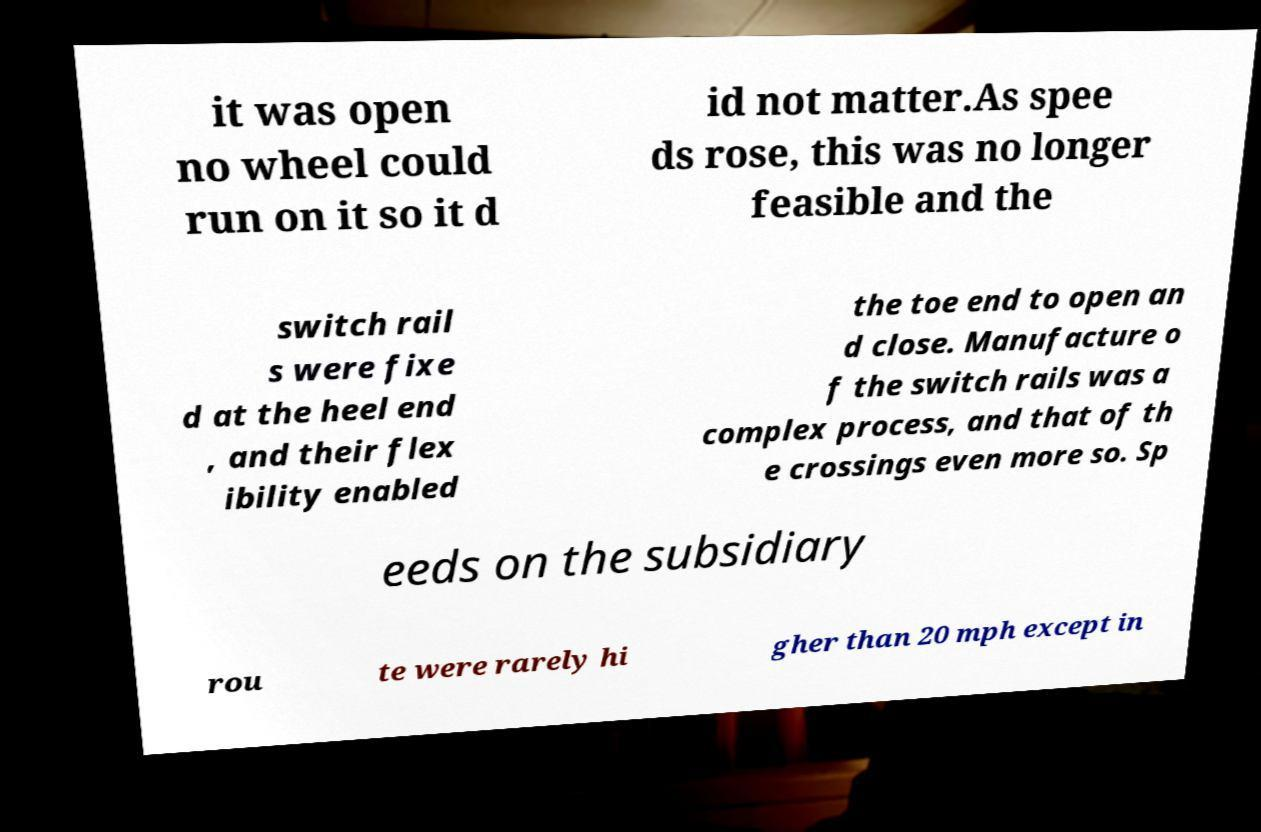I need the written content from this picture converted into text. Can you do that? it was open no wheel could run on it so it d id not matter.As spee ds rose, this was no longer feasible and the switch rail s were fixe d at the heel end , and their flex ibility enabled the toe end to open an d close. Manufacture o f the switch rails was a complex process, and that of th e crossings even more so. Sp eeds on the subsidiary rou te were rarely hi gher than 20 mph except in 